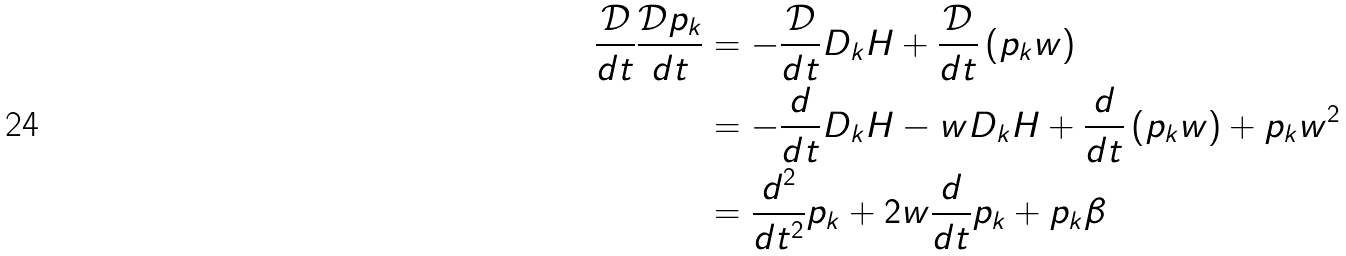<formula> <loc_0><loc_0><loc_500><loc_500>\frac { \mathcal { D } } { d t } \frac { \mathcal { D } { { p } _ { k } } } { d t } & = - \frac { \mathcal { D } } { d t } { { D } _ { k } } H + \frac { \mathcal { D } } { d t } \left ( { { p } _ { k } } w \right ) \\ & = - \frac { d } { d t } { { D } _ { k } } H - w { { D } _ { k } } H + \frac { d } { d t } \left ( { { p } _ { k } } w \right ) + { { p } _ { k } } { { w } ^ { 2 } } \\ & = \frac { { { d } ^ { 2 } } } { d { { t } ^ { 2 } } } { { p } _ { k } } + 2 w \frac { d } { d t } { { p } _ { k } } + { { p } _ { k } } \beta</formula> 